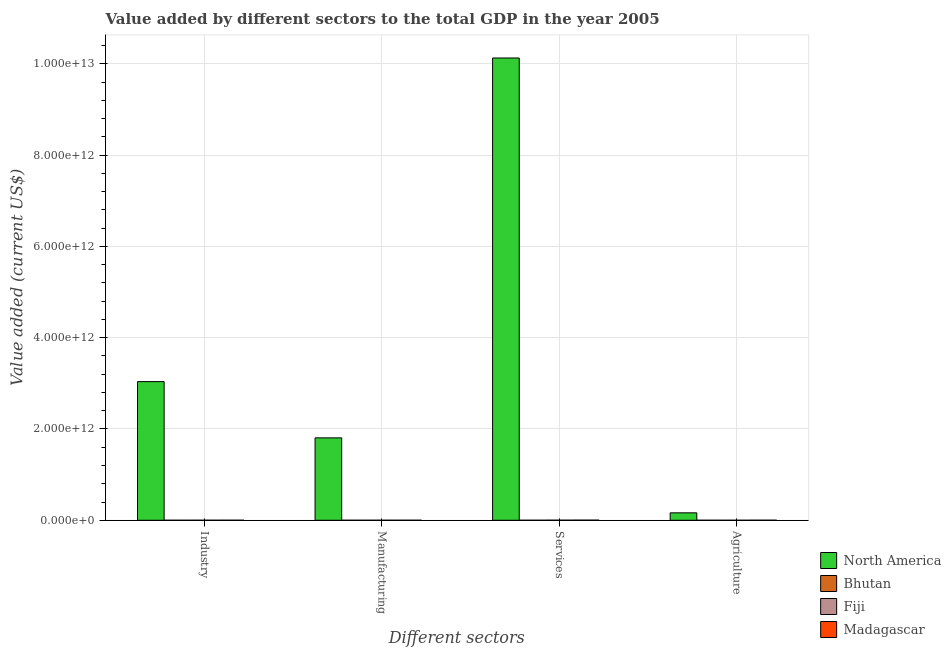Are the number of bars per tick equal to the number of legend labels?
Give a very brief answer. Yes. Are the number of bars on each tick of the X-axis equal?
Keep it short and to the point. Yes. How many bars are there on the 1st tick from the left?
Your answer should be compact. 4. How many bars are there on the 3rd tick from the right?
Offer a very short reply. 4. What is the label of the 2nd group of bars from the left?
Provide a short and direct response. Manufacturing. What is the value added by manufacturing sector in Bhutan?
Keep it short and to the point. 5.83e+07. Across all countries, what is the maximum value added by services sector?
Give a very brief answer. 1.01e+13. Across all countries, what is the minimum value added by services sector?
Ensure brevity in your answer.  3.12e+08. In which country was the value added by industrial sector minimum?
Keep it short and to the point. Bhutan. What is the total value added by industrial sector in the graph?
Your answer should be compact. 3.04e+12. What is the difference between the value added by agricultural sector in Bhutan and that in Madagascar?
Provide a short and direct response. -1.11e+09. What is the difference between the value added by agricultural sector in Bhutan and the value added by manufacturing sector in Fiji?
Offer a terse response. -1.81e+08. What is the average value added by agricultural sector per country?
Give a very brief answer. 4.11e+1. What is the difference between the value added by manufacturing sector and value added by industrial sector in Fiji?
Make the answer very short. -1.26e+08. In how many countries, is the value added by services sector greater than 3600000000000 US$?
Your response must be concise. 1. What is the ratio of the value added by industrial sector in Bhutan to that in Madagascar?
Offer a terse response. 0.41. Is the value added by agricultural sector in Madagascar less than that in Bhutan?
Offer a very short reply. No. What is the difference between the highest and the second highest value added by agricultural sector?
Give a very brief answer. 1.61e+11. What is the difference between the highest and the lowest value added by industrial sector?
Provide a short and direct response. 3.04e+12. What does the 3rd bar from the left in Agriculture represents?
Keep it short and to the point. Fiji. What does the 2nd bar from the right in Services represents?
Make the answer very short. Fiji. How many bars are there?
Ensure brevity in your answer.  16. Are all the bars in the graph horizontal?
Your answer should be very brief. No. How many countries are there in the graph?
Provide a succinct answer. 4. What is the difference between two consecutive major ticks on the Y-axis?
Offer a terse response. 2.00e+12. Are the values on the major ticks of Y-axis written in scientific E-notation?
Keep it short and to the point. Yes. Where does the legend appear in the graph?
Make the answer very short. Bottom right. How are the legend labels stacked?
Your answer should be compact. Vertical. What is the title of the graph?
Give a very brief answer. Value added by different sectors to the total GDP in the year 2005. What is the label or title of the X-axis?
Make the answer very short. Different sectors. What is the label or title of the Y-axis?
Ensure brevity in your answer.  Value added (current US$). What is the Value added (current US$) of North America in Industry?
Your answer should be very brief. 3.04e+12. What is the Value added (current US$) in Bhutan in Industry?
Offer a very short reply. 2.94e+08. What is the Value added (current US$) of Fiji in Industry?
Give a very brief answer. 4.90e+08. What is the Value added (current US$) in Madagascar in Industry?
Provide a short and direct response. 7.21e+08. What is the Value added (current US$) of North America in Manufacturing?
Provide a short and direct response. 1.81e+12. What is the Value added (current US$) in Bhutan in Manufacturing?
Keep it short and to the point. 5.83e+07. What is the Value added (current US$) of Fiji in Manufacturing?
Make the answer very short. 3.64e+08. What is the Value added (current US$) in Madagascar in Manufacturing?
Provide a succinct answer. 6.40e+08. What is the Value added (current US$) of North America in Services?
Keep it short and to the point. 1.01e+13. What is the Value added (current US$) of Bhutan in Services?
Keep it short and to the point. 3.12e+08. What is the Value added (current US$) in Fiji in Services?
Ensure brevity in your answer.  1.71e+09. What is the Value added (current US$) in Madagascar in Services?
Offer a very short reply. 2.56e+09. What is the Value added (current US$) of North America in Agriculture?
Make the answer very short. 1.63e+11. What is the Value added (current US$) in Bhutan in Agriculture?
Ensure brevity in your answer.  1.83e+08. What is the Value added (current US$) in Fiji in Agriculture?
Make the answer very short. 3.60e+08. What is the Value added (current US$) of Madagascar in Agriculture?
Give a very brief answer. 1.29e+09. Across all Different sectors, what is the maximum Value added (current US$) of North America?
Ensure brevity in your answer.  1.01e+13. Across all Different sectors, what is the maximum Value added (current US$) of Bhutan?
Your answer should be compact. 3.12e+08. Across all Different sectors, what is the maximum Value added (current US$) of Fiji?
Provide a succinct answer. 1.71e+09. Across all Different sectors, what is the maximum Value added (current US$) of Madagascar?
Give a very brief answer. 2.56e+09. Across all Different sectors, what is the minimum Value added (current US$) of North America?
Give a very brief answer. 1.63e+11. Across all Different sectors, what is the minimum Value added (current US$) of Bhutan?
Your answer should be compact. 5.83e+07. Across all Different sectors, what is the minimum Value added (current US$) of Fiji?
Give a very brief answer. 3.60e+08. Across all Different sectors, what is the minimum Value added (current US$) in Madagascar?
Ensure brevity in your answer.  6.40e+08. What is the total Value added (current US$) in North America in the graph?
Your answer should be very brief. 1.51e+13. What is the total Value added (current US$) of Bhutan in the graph?
Give a very brief answer. 8.47e+08. What is the total Value added (current US$) in Fiji in the graph?
Keep it short and to the point. 2.92e+09. What is the total Value added (current US$) in Madagascar in the graph?
Offer a terse response. 5.21e+09. What is the difference between the Value added (current US$) of North America in Industry and that in Manufacturing?
Offer a very short reply. 1.23e+12. What is the difference between the Value added (current US$) in Bhutan in Industry and that in Manufacturing?
Give a very brief answer. 2.36e+08. What is the difference between the Value added (current US$) in Fiji in Industry and that in Manufacturing?
Provide a short and direct response. 1.26e+08. What is the difference between the Value added (current US$) in Madagascar in Industry and that in Manufacturing?
Your response must be concise. 8.15e+07. What is the difference between the Value added (current US$) of North America in Industry and that in Services?
Your answer should be compact. -7.09e+12. What is the difference between the Value added (current US$) of Bhutan in Industry and that in Services?
Provide a succinct answer. -1.77e+07. What is the difference between the Value added (current US$) in Fiji in Industry and that in Services?
Provide a succinct answer. -1.22e+09. What is the difference between the Value added (current US$) of Madagascar in Industry and that in Services?
Offer a terse response. -1.84e+09. What is the difference between the Value added (current US$) of North America in Industry and that in Agriculture?
Give a very brief answer. 2.87e+12. What is the difference between the Value added (current US$) of Bhutan in Industry and that in Agriculture?
Provide a succinct answer. 1.11e+08. What is the difference between the Value added (current US$) in Fiji in Industry and that in Agriculture?
Your answer should be compact. 1.30e+08. What is the difference between the Value added (current US$) of Madagascar in Industry and that in Agriculture?
Offer a very short reply. -5.73e+08. What is the difference between the Value added (current US$) in North America in Manufacturing and that in Services?
Provide a short and direct response. -8.32e+12. What is the difference between the Value added (current US$) in Bhutan in Manufacturing and that in Services?
Make the answer very short. -2.54e+08. What is the difference between the Value added (current US$) of Fiji in Manufacturing and that in Services?
Keep it short and to the point. -1.34e+09. What is the difference between the Value added (current US$) of Madagascar in Manufacturing and that in Services?
Offer a very short reply. -1.92e+09. What is the difference between the Value added (current US$) in North America in Manufacturing and that in Agriculture?
Your response must be concise. 1.64e+12. What is the difference between the Value added (current US$) of Bhutan in Manufacturing and that in Agriculture?
Your response must be concise. -1.25e+08. What is the difference between the Value added (current US$) of Fiji in Manufacturing and that in Agriculture?
Offer a terse response. 4.20e+06. What is the difference between the Value added (current US$) of Madagascar in Manufacturing and that in Agriculture?
Your answer should be very brief. -6.54e+08. What is the difference between the Value added (current US$) in North America in Services and that in Agriculture?
Offer a very short reply. 9.96e+12. What is the difference between the Value added (current US$) in Bhutan in Services and that in Agriculture?
Make the answer very short. 1.29e+08. What is the difference between the Value added (current US$) in Fiji in Services and that in Agriculture?
Offer a terse response. 1.35e+09. What is the difference between the Value added (current US$) in Madagascar in Services and that in Agriculture?
Provide a succinct answer. 1.26e+09. What is the difference between the Value added (current US$) in North America in Industry and the Value added (current US$) in Bhutan in Manufacturing?
Your answer should be very brief. 3.04e+12. What is the difference between the Value added (current US$) of North America in Industry and the Value added (current US$) of Fiji in Manufacturing?
Give a very brief answer. 3.04e+12. What is the difference between the Value added (current US$) in North America in Industry and the Value added (current US$) in Madagascar in Manufacturing?
Offer a terse response. 3.04e+12. What is the difference between the Value added (current US$) in Bhutan in Industry and the Value added (current US$) in Fiji in Manufacturing?
Offer a terse response. -6.99e+07. What is the difference between the Value added (current US$) of Bhutan in Industry and the Value added (current US$) of Madagascar in Manufacturing?
Offer a very short reply. -3.46e+08. What is the difference between the Value added (current US$) in Fiji in Industry and the Value added (current US$) in Madagascar in Manufacturing?
Keep it short and to the point. -1.50e+08. What is the difference between the Value added (current US$) in North America in Industry and the Value added (current US$) in Bhutan in Services?
Provide a succinct answer. 3.04e+12. What is the difference between the Value added (current US$) of North America in Industry and the Value added (current US$) of Fiji in Services?
Ensure brevity in your answer.  3.04e+12. What is the difference between the Value added (current US$) of North America in Industry and the Value added (current US$) of Madagascar in Services?
Your answer should be very brief. 3.03e+12. What is the difference between the Value added (current US$) of Bhutan in Industry and the Value added (current US$) of Fiji in Services?
Give a very brief answer. -1.41e+09. What is the difference between the Value added (current US$) in Bhutan in Industry and the Value added (current US$) in Madagascar in Services?
Make the answer very short. -2.26e+09. What is the difference between the Value added (current US$) in Fiji in Industry and the Value added (current US$) in Madagascar in Services?
Provide a short and direct response. -2.07e+09. What is the difference between the Value added (current US$) in North America in Industry and the Value added (current US$) in Bhutan in Agriculture?
Your answer should be compact. 3.04e+12. What is the difference between the Value added (current US$) in North America in Industry and the Value added (current US$) in Fiji in Agriculture?
Offer a very short reply. 3.04e+12. What is the difference between the Value added (current US$) in North America in Industry and the Value added (current US$) in Madagascar in Agriculture?
Provide a short and direct response. 3.04e+12. What is the difference between the Value added (current US$) in Bhutan in Industry and the Value added (current US$) in Fiji in Agriculture?
Your answer should be very brief. -6.57e+07. What is the difference between the Value added (current US$) of Bhutan in Industry and the Value added (current US$) of Madagascar in Agriculture?
Your response must be concise. -1.00e+09. What is the difference between the Value added (current US$) in Fiji in Industry and the Value added (current US$) in Madagascar in Agriculture?
Offer a terse response. -8.04e+08. What is the difference between the Value added (current US$) of North America in Manufacturing and the Value added (current US$) of Bhutan in Services?
Provide a succinct answer. 1.80e+12. What is the difference between the Value added (current US$) in North America in Manufacturing and the Value added (current US$) in Fiji in Services?
Your response must be concise. 1.80e+12. What is the difference between the Value added (current US$) of North America in Manufacturing and the Value added (current US$) of Madagascar in Services?
Your response must be concise. 1.80e+12. What is the difference between the Value added (current US$) in Bhutan in Manufacturing and the Value added (current US$) in Fiji in Services?
Provide a short and direct response. -1.65e+09. What is the difference between the Value added (current US$) in Bhutan in Manufacturing and the Value added (current US$) in Madagascar in Services?
Offer a very short reply. -2.50e+09. What is the difference between the Value added (current US$) in Fiji in Manufacturing and the Value added (current US$) in Madagascar in Services?
Your answer should be compact. -2.19e+09. What is the difference between the Value added (current US$) of North America in Manufacturing and the Value added (current US$) of Bhutan in Agriculture?
Make the answer very short. 1.80e+12. What is the difference between the Value added (current US$) in North America in Manufacturing and the Value added (current US$) in Fiji in Agriculture?
Make the answer very short. 1.80e+12. What is the difference between the Value added (current US$) in North America in Manufacturing and the Value added (current US$) in Madagascar in Agriculture?
Keep it short and to the point. 1.80e+12. What is the difference between the Value added (current US$) of Bhutan in Manufacturing and the Value added (current US$) of Fiji in Agriculture?
Keep it short and to the point. -3.02e+08. What is the difference between the Value added (current US$) of Bhutan in Manufacturing and the Value added (current US$) of Madagascar in Agriculture?
Keep it short and to the point. -1.24e+09. What is the difference between the Value added (current US$) in Fiji in Manufacturing and the Value added (current US$) in Madagascar in Agriculture?
Offer a very short reply. -9.30e+08. What is the difference between the Value added (current US$) in North America in Services and the Value added (current US$) in Bhutan in Agriculture?
Offer a very short reply. 1.01e+13. What is the difference between the Value added (current US$) in North America in Services and the Value added (current US$) in Fiji in Agriculture?
Ensure brevity in your answer.  1.01e+13. What is the difference between the Value added (current US$) in North America in Services and the Value added (current US$) in Madagascar in Agriculture?
Provide a succinct answer. 1.01e+13. What is the difference between the Value added (current US$) in Bhutan in Services and the Value added (current US$) in Fiji in Agriculture?
Ensure brevity in your answer.  -4.80e+07. What is the difference between the Value added (current US$) of Bhutan in Services and the Value added (current US$) of Madagascar in Agriculture?
Your answer should be very brief. -9.82e+08. What is the difference between the Value added (current US$) in Fiji in Services and the Value added (current US$) in Madagascar in Agriculture?
Keep it short and to the point. 4.15e+08. What is the average Value added (current US$) of North America per Different sectors?
Make the answer very short. 3.78e+12. What is the average Value added (current US$) in Bhutan per Different sectors?
Offer a terse response. 2.12e+08. What is the average Value added (current US$) in Fiji per Different sectors?
Provide a succinct answer. 7.31e+08. What is the average Value added (current US$) of Madagascar per Different sectors?
Provide a short and direct response. 1.30e+09. What is the difference between the Value added (current US$) in North America and Value added (current US$) in Bhutan in Industry?
Give a very brief answer. 3.04e+12. What is the difference between the Value added (current US$) in North America and Value added (current US$) in Fiji in Industry?
Ensure brevity in your answer.  3.04e+12. What is the difference between the Value added (current US$) in North America and Value added (current US$) in Madagascar in Industry?
Offer a very short reply. 3.04e+12. What is the difference between the Value added (current US$) of Bhutan and Value added (current US$) of Fiji in Industry?
Your response must be concise. -1.96e+08. What is the difference between the Value added (current US$) in Bhutan and Value added (current US$) in Madagascar in Industry?
Provide a succinct answer. -4.27e+08. What is the difference between the Value added (current US$) of Fiji and Value added (current US$) of Madagascar in Industry?
Your response must be concise. -2.31e+08. What is the difference between the Value added (current US$) in North America and Value added (current US$) in Bhutan in Manufacturing?
Make the answer very short. 1.81e+12. What is the difference between the Value added (current US$) in North America and Value added (current US$) in Fiji in Manufacturing?
Ensure brevity in your answer.  1.80e+12. What is the difference between the Value added (current US$) of North America and Value added (current US$) of Madagascar in Manufacturing?
Offer a terse response. 1.80e+12. What is the difference between the Value added (current US$) in Bhutan and Value added (current US$) in Fiji in Manufacturing?
Ensure brevity in your answer.  -3.06e+08. What is the difference between the Value added (current US$) in Bhutan and Value added (current US$) in Madagascar in Manufacturing?
Your answer should be compact. -5.82e+08. What is the difference between the Value added (current US$) in Fiji and Value added (current US$) in Madagascar in Manufacturing?
Offer a very short reply. -2.76e+08. What is the difference between the Value added (current US$) of North America and Value added (current US$) of Bhutan in Services?
Make the answer very short. 1.01e+13. What is the difference between the Value added (current US$) in North America and Value added (current US$) in Fiji in Services?
Your answer should be compact. 1.01e+13. What is the difference between the Value added (current US$) in North America and Value added (current US$) in Madagascar in Services?
Keep it short and to the point. 1.01e+13. What is the difference between the Value added (current US$) in Bhutan and Value added (current US$) in Fiji in Services?
Your answer should be compact. -1.40e+09. What is the difference between the Value added (current US$) of Bhutan and Value added (current US$) of Madagascar in Services?
Ensure brevity in your answer.  -2.25e+09. What is the difference between the Value added (current US$) in Fiji and Value added (current US$) in Madagascar in Services?
Your answer should be compact. -8.50e+08. What is the difference between the Value added (current US$) of North America and Value added (current US$) of Bhutan in Agriculture?
Make the answer very short. 1.63e+11. What is the difference between the Value added (current US$) in North America and Value added (current US$) in Fiji in Agriculture?
Provide a short and direct response. 1.62e+11. What is the difference between the Value added (current US$) of North America and Value added (current US$) of Madagascar in Agriculture?
Your answer should be compact. 1.61e+11. What is the difference between the Value added (current US$) of Bhutan and Value added (current US$) of Fiji in Agriculture?
Provide a succinct answer. -1.77e+08. What is the difference between the Value added (current US$) of Bhutan and Value added (current US$) of Madagascar in Agriculture?
Your answer should be very brief. -1.11e+09. What is the difference between the Value added (current US$) in Fiji and Value added (current US$) in Madagascar in Agriculture?
Offer a very short reply. -9.34e+08. What is the ratio of the Value added (current US$) in North America in Industry to that in Manufacturing?
Provide a short and direct response. 1.68. What is the ratio of the Value added (current US$) of Bhutan in Industry to that in Manufacturing?
Your answer should be compact. 5.05. What is the ratio of the Value added (current US$) in Fiji in Industry to that in Manufacturing?
Give a very brief answer. 1.35. What is the ratio of the Value added (current US$) of Madagascar in Industry to that in Manufacturing?
Offer a terse response. 1.13. What is the ratio of the Value added (current US$) in North America in Industry to that in Services?
Give a very brief answer. 0.3. What is the ratio of the Value added (current US$) in Bhutan in Industry to that in Services?
Give a very brief answer. 0.94. What is the ratio of the Value added (current US$) in Fiji in Industry to that in Services?
Provide a succinct answer. 0.29. What is the ratio of the Value added (current US$) in Madagascar in Industry to that in Services?
Offer a terse response. 0.28. What is the ratio of the Value added (current US$) of North America in Industry to that in Agriculture?
Offer a terse response. 18.67. What is the ratio of the Value added (current US$) in Bhutan in Industry to that in Agriculture?
Provide a short and direct response. 1.61. What is the ratio of the Value added (current US$) in Fiji in Industry to that in Agriculture?
Keep it short and to the point. 1.36. What is the ratio of the Value added (current US$) in Madagascar in Industry to that in Agriculture?
Provide a succinct answer. 0.56. What is the ratio of the Value added (current US$) of North America in Manufacturing to that in Services?
Provide a succinct answer. 0.18. What is the ratio of the Value added (current US$) in Bhutan in Manufacturing to that in Services?
Your answer should be very brief. 0.19. What is the ratio of the Value added (current US$) of Fiji in Manufacturing to that in Services?
Make the answer very short. 0.21. What is the ratio of the Value added (current US$) in Madagascar in Manufacturing to that in Services?
Offer a very short reply. 0.25. What is the ratio of the Value added (current US$) of North America in Manufacturing to that in Agriculture?
Your answer should be compact. 11.09. What is the ratio of the Value added (current US$) in Bhutan in Manufacturing to that in Agriculture?
Your answer should be very brief. 0.32. What is the ratio of the Value added (current US$) of Fiji in Manufacturing to that in Agriculture?
Your response must be concise. 1.01. What is the ratio of the Value added (current US$) of Madagascar in Manufacturing to that in Agriculture?
Your answer should be very brief. 0.49. What is the ratio of the Value added (current US$) of North America in Services to that in Agriculture?
Offer a terse response. 62.23. What is the ratio of the Value added (current US$) of Bhutan in Services to that in Agriculture?
Your answer should be compact. 1.71. What is the ratio of the Value added (current US$) of Fiji in Services to that in Agriculture?
Keep it short and to the point. 4.75. What is the ratio of the Value added (current US$) of Madagascar in Services to that in Agriculture?
Ensure brevity in your answer.  1.98. What is the difference between the highest and the second highest Value added (current US$) in North America?
Keep it short and to the point. 7.09e+12. What is the difference between the highest and the second highest Value added (current US$) of Bhutan?
Ensure brevity in your answer.  1.77e+07. What is the difference between the highest and the second highest Value added (current US$) of Fiji?
Offer a very short reply. 1.22e+09. What is the difference between the highest and the second highest Value added (current US$) in Madagascar?
Your response must be concise. 1.26e+09. What is the difference between the highest and the lowest Value added (current US$) of North America?
Provide a short and direct response. 9.96e+12. What is the difference between the highest and the lowest Value added (current US$) in Bhutan?
Your answer should be very brief. 2.54e+08. What is the difference between the highest and the lowest Value added (current US$) in Fiji?
Your answer should be very brief. 1.35e+09. What is the difference between the highest and the lowest Value added (current US$) in Madagascar?
Your answer should be compact. 1.92e+09. 